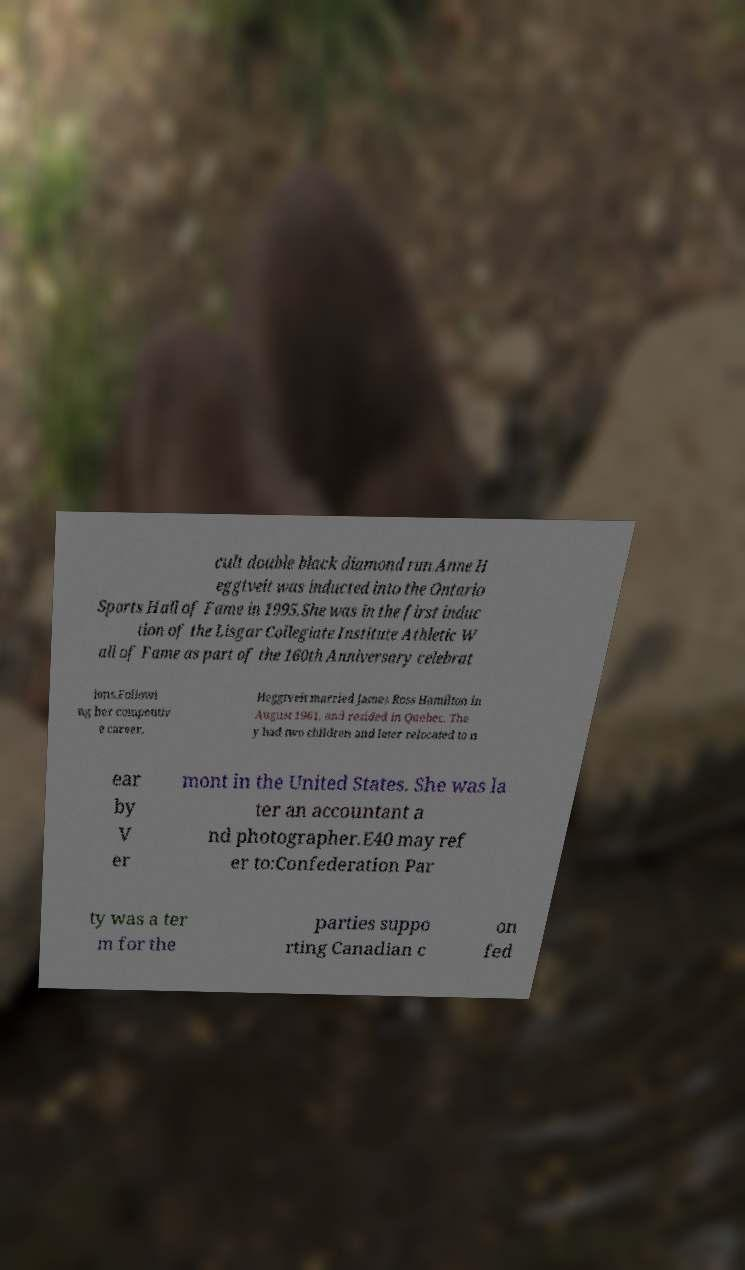Can you accurately transcribe the text from the provided image for me? cult double black diamond run.Anne H eggtveit was inducted into the Ontario Sports Hall of Fame in 1995.She was in the first induc tion of the Lisgar Collegiate Institute Athletic W all of Fame as part of the 160th Anniversary celebrat ions.Followi ng her competitiv e career, Heggtveit married James Ross Hamilton in August 1961, and resided in Quebec. The y had two children and later relocated to n ear by V er mont in the United States. She was la ter an accountant a nd photographer.E40 may ref er to:Confederation Par ty was a ter m for the parties suppo rting Canadian c on fed 